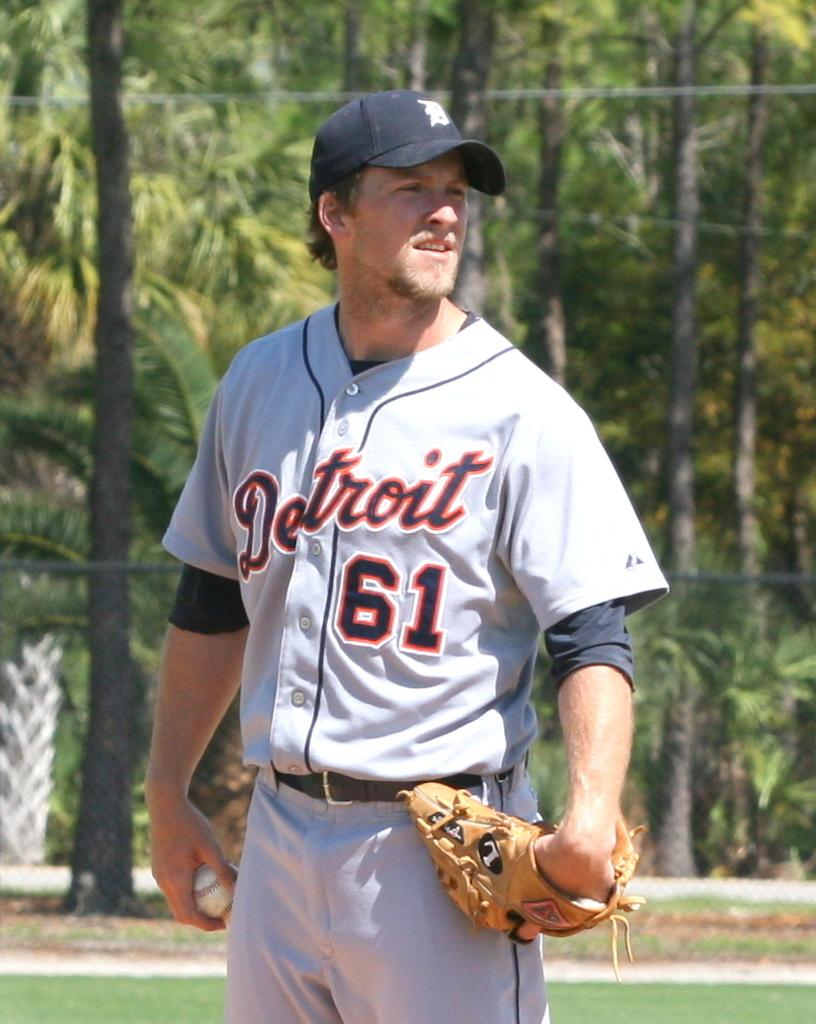Provide a one-sentence caption for the provided image. A Detroit player wearing 61 standing on a field. 